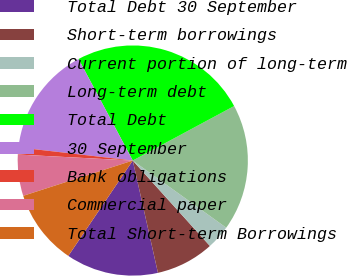<chart> <loc_0><loc_0><loc_500><loc_500><pie_chart><fcel>Total Debt 30 September<fcel>Short-term borrowings<fcel>Current portion of long-term<fcel>Long-term debt<fcel>Total Debt<fcel>30 September<fcel>Bank obligations<fcel>Commercial paper<fcel>Total Short-term Borrowings<nl><fcel>12.97%<fcel>8.18%<fcel>3.39%<fcel>17.77%<fcel>24.95%<fcel>15.37%<fcel>0.99%<fcel>5.79%<fcel>10.58%<nl></chart> 